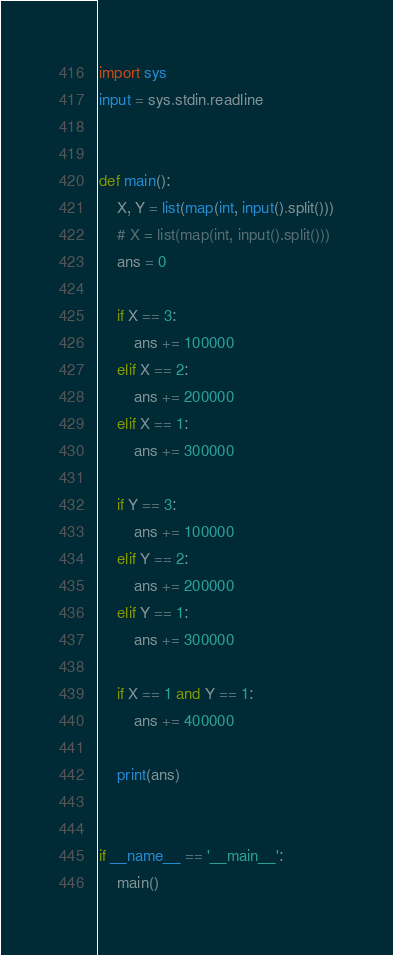Convert code to text. <code><loc_0><loc_0><loc_500><loc_500><_Python_>import sys
input = sys.stdin.readline


def main():
    X, Y = list(map(int, input().split()))
    # X = list(map(int, input().split()))
    ans = 0

    if X == 3:
        ans += 100000
    elif X == 2:
        ans += 200000
    elif X == 1:
        ans += 300000

    if Y == 3:
        ans += 100000
    elif Y == 2:
        ans += 200000
    elif Y == 1:
        ans += 300000

    if X == 1 and Y == 1:
        ans += 400000

    print(ans)


if __name__ == '__main__':
    main()
</code> 